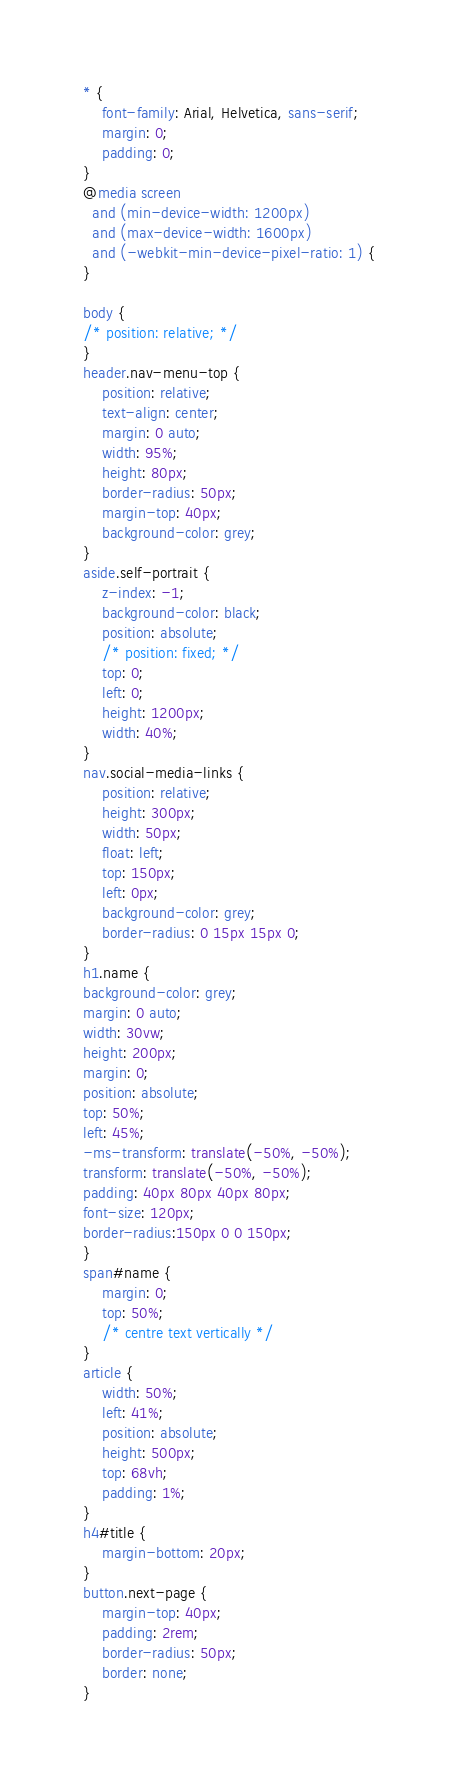Convert code to text. <code><loc_0><loc_0><loc_500><loc_500><_CSS_>
* {
    font-family: Arial, Helvetica, sans-serif;
    margin: 0;
    padding: 0;
}
@media screen 
  and (min-device-width: 1200px) 
  and (max-device-width: 1600px) 
  and (-webkit-min-device-pixel-ratio: 1) { 
}

body {
/* position: relative; */
}
header.nav-menu-top {
    position: relative;
    text-align: center;
    margin: 0 auto;
    width: 95%;
    height: 80px;
    border-radius: 50px;
    margin-top: 40px;
    background-color: grey;
}
aside.self-portrait {
    z-index: -1;
    background-color: black;
    position: absolute;
    /* position: fixed; */
    top: 0;
    left: 0;
    height: 1200px;
    width: 40%;
}
nav.social-media-links {
    position: relative;
    height: 300px;
    width: 50px;
    float: left;
    top: 150px;
    left: 0px;
    background-color: grey;
    border-radius: 0 15px 15px 0;
}
h1.name {
background-color: grey;
margin: 0 auto;
width: 30vw;
height: 200px;
margin: 0;
position: absolute;
top: 50%;
left: 45%;
-ms-transform: translate(-50%, -50%);
transform: translate(-50%, -50%);
padding: 40px 80px 40px 80px;
font-size: 120px;
border-radius:150px 0 0 150px;
}
span#name {
    margin: 0;
    top: 50%;
    /* centre text vertically */
}
article {
    width: 50%;
    left: 41%;
    position: absolute;
    height: 500px;
    top: 68vh;
    padding: 1%;
}
h4#title {
    margin-bottom: 20px;
}
button.next-page {
    margin-top: 40px;
    padding: 2rem;
    border-radius: 50px;
    border: none;
}
</code> 